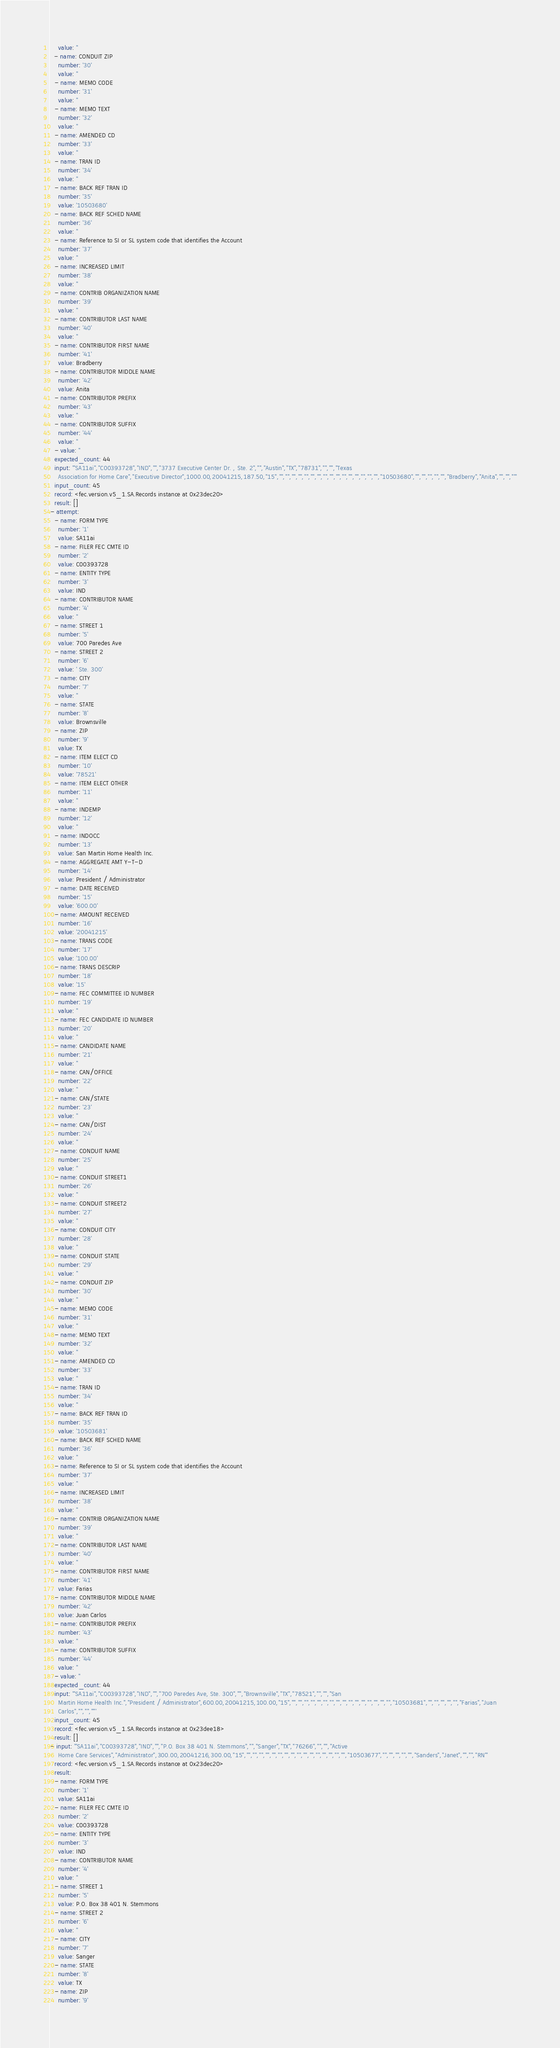Convert code to text. <code><loc_0><loc_0><loc_500><loc_500><_YAML_>    value: ''
  - name: CONDUIT ZIP
    number: '30'
    value: ''
  - name: MEMO CODE
    number: '31'
    value: ''
  - name: MEMO TEXT
    number: '32'
    value: ''
  - name: AMENDED CD
    number: '33'
    value: ''
  - name: TRAN ID
    number: '34'
    value: ''
  - name: BACK REF TRAN ID
    number: '35'
    value: '10503680'
  - name: BACK REF SCHED NAME
    number: '36'
    value: ''
  - name: Reference to SI or SL system code that identifies the Account
    number: '37'
    value: ''
  - name: INCREASED LIMIT
    number: '38'
    value: ''
  - name: CONTRIB ORGANIZATION NAME
    number: '39'
    value: ''
  - name: CONTRIBUTOR LAST NAME
    number: '40'
    value: ''
  - name: CONTRIBUTOR FIRST NAME
    number: '41'
    value: Bradberry
  - name: CONTRIBUTOR MIDDLE NAME
    number: '42'
    value: Anita
  - name: CONTRIBUTOR PREFIX
    number: '43'
    value: ''
  - name: CONTRIBUTOR SUFFIX
    number: '44'
    value: ''
  - value: ''
  expected_count: 44
  input: '"SA11ai","C00393728","IND","","3737 Executive Center Dr. , Ste. 2","","Austin","TX","78731","","","Texas
    Association for Home Care","Executive Director",1000.00,20041215,187.50,"15","","","","","","","","","","","","","","","","","10503680","","","","","","Bradberry","Anita","","",""'
  input_count: 45
  record: <fec.version.v5_1.SA.Records instance at 0x23dec20>
  result: []
- attempt:
  - name: FORM TYPE
    number: '1'
    value: SA11ai
  - name: FILER FEC CMTE ID
    number: '2'
    value: C00393728
  - name: ENTITY TYPE
    number: '3'
    value: IND
  - name: CONTRIBUTOR NAME
    number: '4'
    value: ''
  - name: STREET 1
    number: '5'
    value: 700 Paredes Ave
  - name: STREET 2
    number: '6'
    value: ' Ste. 300'
  - name: CITY
    number: '7'
    value: ''
  - name: STATE
    number: '8'
    value: Brownsville
  - name: ZIP
    number: '9'
    value: TX
  - name: ITEM ELECT CD
    number: '10'
    value: '78521'
  - name: ITEM ELECT OTHER
    number: '11'
    value: ''
  - name: INDEMP
    number: '12'
    value: ''
  - name: INDOCC
    number: '13'
    value: San Martin Home Health Inc.
  - name: AGGREGATE AMT Y-T-D
    number: '14'
    value: President / Administrator
  - name: DATE RECEIVED
    number: '15'
    value: '600.00'
  - name: AMOUNT RECEIVED
    number: '16'
    value: '20041215'
  - name: TRANS CODE
    number: '17'
    value: '100.00'
  - name: TRANS DESCRIP
    number: '18'
    value: '15'
  - name: FEC COMMITTEE ID NUMBER
    number: '19'
    value: ''
  - name: FEC CANDIDATE ID NUMBER
    number: '20'
    value: ''
  - name: CANDIDATE NAME
    number: '21'
    value: ''
  - name: CAN/OFFICE
    number: '22'
    value: ''
  - name: CAN/STATE
    number: '23'
    value: ''
  - name: CAN/DIST
    number: '24'
    value: ''
  - name: CONDUIT NAME
    number: '25'
    value: ''
  - name: CONDUIT STREET1
    number: '26'
    value: ''
  - name: CONDUIT STREET2
    number: '27'
    value: ''
  - name: CONDUIT CITY
    number: '28'
    value: ''
  - name: CONDUIT STATE
    number: '29'
    value: ''
  - name: CONDUIT ZIP
    number: '30'
    value: ''
  - name: MEMO CODE
    number: '31'
    value: ''
  - name: MEMO TEXT
    number: '32'
    value: ''
  - name: AMENDED CD
    number: '33'
    value: ''
  - name: TRAN ID
    number: '34'
    value: ''
  - name: BACK REF TRAN ID
    number: '35'
    value: '10503681'
  - name: BACK REF SCHED NAME
    number: '36'
    value: ''
  - name: Reference to SI or SL system code that identifies the Account
    number: '37'
    value: ''
  - name: INCREASED LIMIT
    number: '38'
    value: ''
  - name: CONTRIB ORGANIZATION NAME
    number: '39'
    value: ''
  - name: CONTRIBUTOR LAST NAME
    number: '40'
    value: ''
  - name: CONTRIBUTOR FIRST NAME
    number: '41'
    value: Farias
  - name: CONTRIBUTOR MIDDLE NAME
    number: '42'
    value: Juan Carlos
  - name: CONTRIBUTOR PREFIX
    number: '43'
    value: ''
  - name: CONTRIBUTOR SUFFIX
    number: '44'
    value: ''
  - value: ''
  expected_count: 44
  input: '"SA11ai","C00393728","IND","","700 Paredes Ave, Ste. 300","","Brownsville","TX","78521","","","San
    Martin Home Health Inc.","President / Administrator",600.00,20041215,100.00,"15","","","","","","","","","","","","","","","","","10503681","","","","","","Farias","Juan
    Carlos","","",""'
  input_count: 45
  record: <fec.version.v5_1.SA.Records instance at 0x23dee18>
  result: []
- input: '"SA11ai","C00393728","IND","","P.O. Box 38 401 N. Stemmons","","Sanger","TX","76266","","","Active
    Home Care Services","Administrator",300.00,20041216,300.00,"15","","","","","","","","","","","","","","","","","10503677","","","","","","Sanders","Janet","","","RN"'
  record: <fec.version.v5_1.SA.Records instance at 0x23dec20>
  result:
  - name: FORM TYPE
    number: '1'
    value: SA11ai
  - name: FILER FEC CMTE ID
    number: '2'
    value: C00393728
  - name: ENTITY TYPE
    number: '3'
    value: IND
  - name: CONTRIBUTOR NAME
    number: '4'
    value: ''
  - name: STREET 1
    number: '5'
    value: P.O. Box 38 401 N. Stemmons
  - name: STREET 2
    number: '6'
    value: ''
  - name: CITY
    number: '7'
    value: Sanger
  - name: STATE
    number: '8'
    value: TX
  - name: ZIP
    number: '9'</code> 